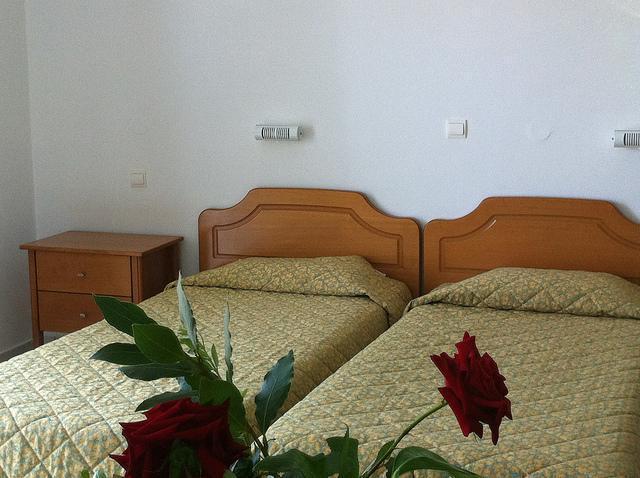How many beds are there?
Give a very brief answer. 2. How many elephants are in this scene?
Give a very brief answer. 0. 